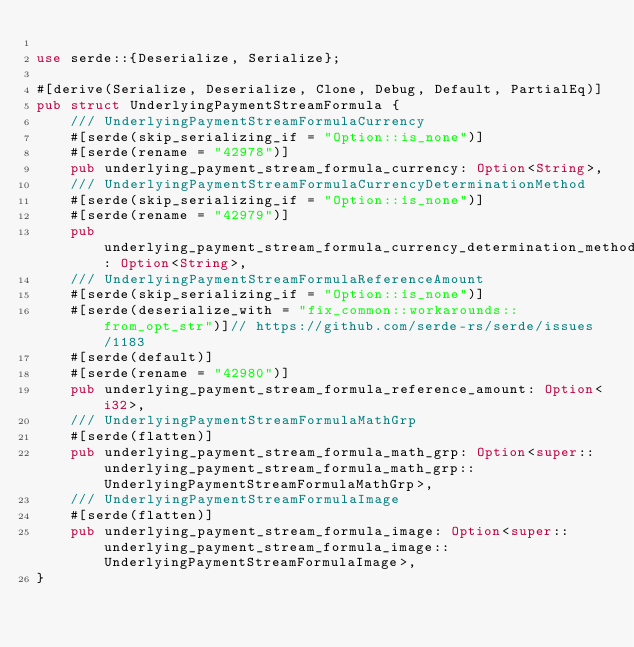<code> <loc_0><loc_0><loc_500><loc_500><_Rust_>
use serde::{Deserialize, Serialize};

#[derive(Serialize, Deserialize, Clone, Debug, Default, PartialEq)]
pub struct UnderlyingPaymentStreamFormula {
	/// UnderlyingPaymentStreamFormulaCurrency
	#[serde(skip_serializing_if = "Option::is_none")]
	#[serde(rename = "42978")]
	pub underlying_payment_stream_formula_currency: Option<String>,
	/// UnderlyingPaymentStreamFormulaCurrencyDeterminationMethod
	#[serde(skip_serializing_if = "Option::is_none")]
	#[serde(rename = "42979")]
	pub underlying_payment_stream_formula_currency_determination_method: Option<String>,
	/// UnderlyingPaymentStreamFormulaReferenceAmount
	#[serde(skip_serializing_if = "Option::is_none")]
	#[serde(deserialize_with = "fix_common::workarounds::from_opt_str")]// https://github.com/serde-rs/serde/issues/1183
	#[serde(default)]
	#[serde(rename = "42980")]
	pub underlying_payment_stream_formula_reference_amount: Option<i32>,
	/// UnderlyingPaymentStreamFormulaMathGrp
	#[serde(flatten)]
	pub underlying_payment_stream_formula_math_grp: Option<super::underlying_payment_stream_formula_math_grp::UnderlyingPaymentStreamFormulaMathGrp>,
	/// UnderlyingPaymentStreamFormulaImage
	#[serde(flatten)]
	pub underlying_payment_stream_formula_image: Option<super::underlying_payment_stream_formula_image::UnderlyingPaymentStreamFormulaImage>,
}
</code> 